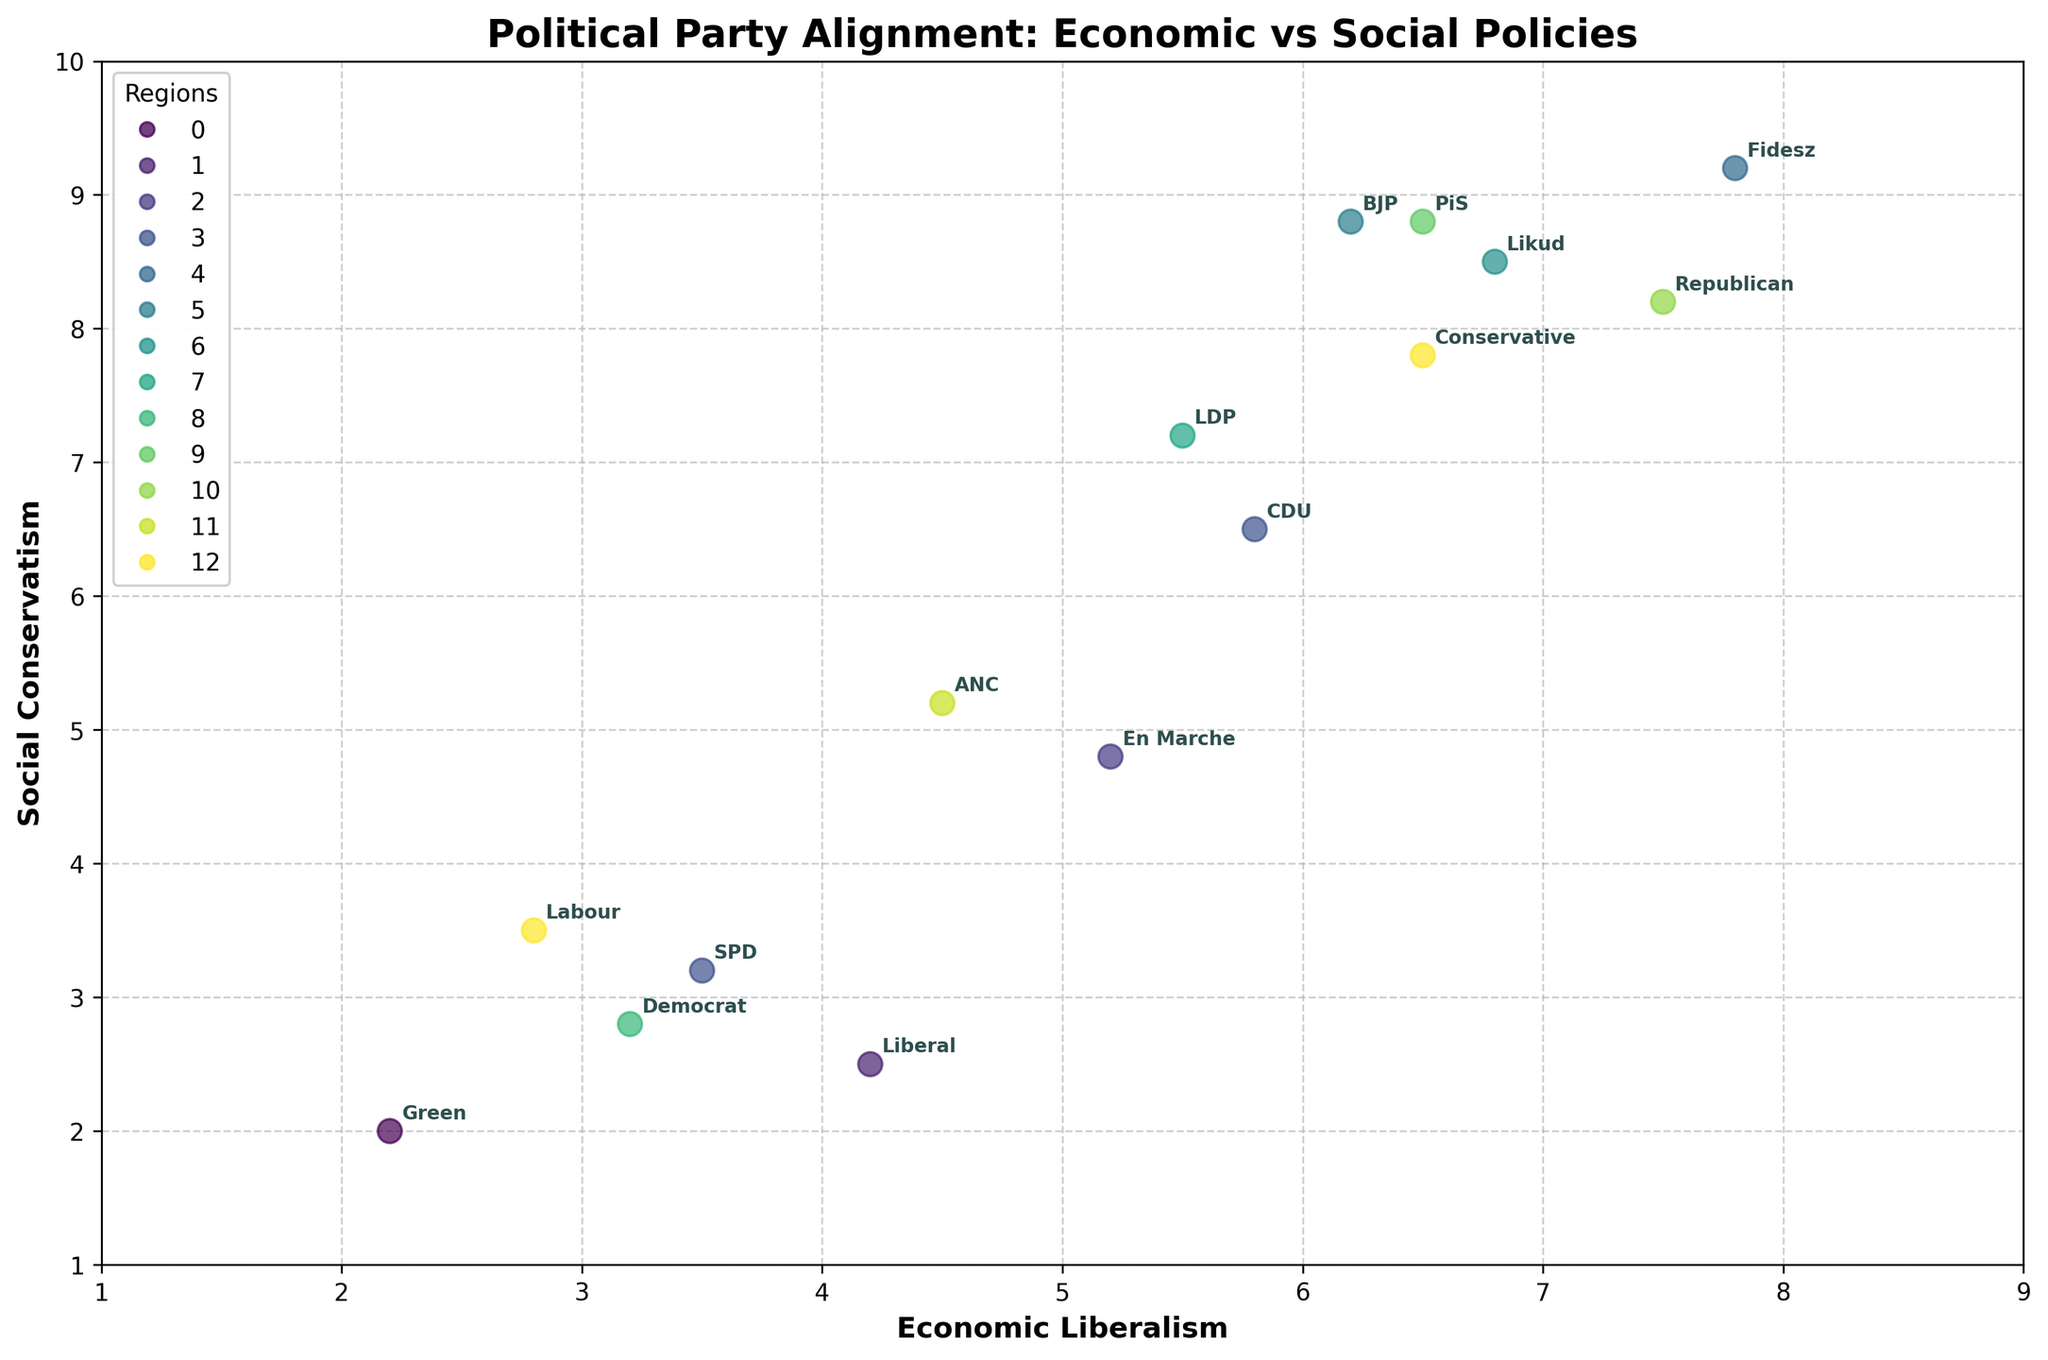What is the title of the figure? The title is usually located at the top center of the figure. In this case, the title of the figure is located there as well.
Answer: Political Party Alignment: Economic vs Social Policies How many political parties are displayed in the figure? By counting the number of labels (party names) annotated in the figure, we can see that there are 15 distinct political parties.
Answer: 15 Which region's political party is located at the top-right corner of the figure? By identifying the points with the highest values on both the x and y axes and checking their corresponding labels, we see that the party in the top-right corner is "Fidesz," and its region is Hungary.
Answer: Hungary Which political party has the lowest economic liberalism score? By identifying the point with the smallest x-value (Economic Liberalism) and checking its corresponding label, we see that the "Green" party has the lowest score.
Answer: Green What is the range of the social conservatism values? The smallest value on the y-axis (Social Conservatism) is 2.0, corresponding to the "Green" party from Australia, and the largest value is 9.2, corresponding to "Fidesz" from Hungary. The range is the difference between these two values: 9.2 - 2.0 = 7.2.
Answer: 7.2 Which region has the most diverse range of political party alignments? By observing the spread of points with the same color (representing the same region), we notice that the South has the most varied range of alignments, as the points are spread widely on both axes, representing the Republican party.
Answer: South What is the average social conservatism score of the UK political parties? There are two political parties from the UK: Labour (3.5) and Conservative (7.8). The average is calculated as (3.5 + 7.8) / 2 = 5.65.
Answer: 5.65 Which political party is closest to the midpoint of the axes? The midpoint of the axes would be the point (5, 5). By identifying the party whose coordinates are closest to this midpoint, we can infer that "En Marche" (5.2, 4.8) is closest to it.
Answer: En Marche Are there any political parties from Germany in the figure? If so, which ones? By observing the labels and their corresponding regions, we find that there are two parties from Germany: CDU and SPD.
Answer: CDU and SPD Which political party has a higher economic liberalism score, Likud or BJP? By comparing the Economic Liberalism scores of Likud and BJP from the x-axis values, Likud has a score of 6.8, and BJP has a score of 6.2. Hence, Likud has a higher score.
Answer: Likud 